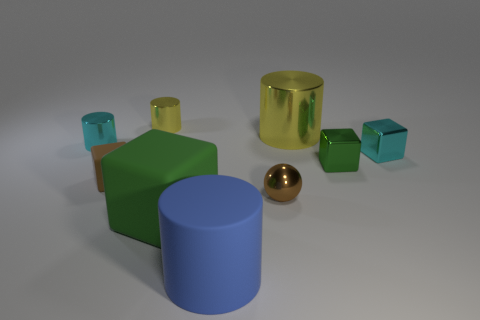What shape is the brown object on the right side of the green matte block?
Your answer should be compact. Sphere. The green metal thing that is the same size as the cyan cube is what shape?
Give a very brief answer. Cube. The large object that is to the right of the big cylinder that is in front of the tiny cyan object left of the big cube is what color?
Your response must be concise. Yellow. Do the large shiny object and the blue rubber thing have the same shape?
Give a very brief answer. Yes. Is the number of big green blocks in front of the large rubber cylinder the same as the number of small green cubes?
Make the answer very short. No. How many other objects are there of the same material as the blue object?
Make the answer very short. 2. Do the metal object that is in front of the small brown rubber thing and the metallic cylinder on the right side of the green rubber object have the same size?
Provide a succinct answer. No. How many things are cyan shiny objects behind the cyan block or tiny blocks that are on the right side of the green matte object?
Your response must be concise. 3. Are there any other things that have the same shape as the small green metallic thing?
Ensure brevity in your answer.  Yes. There is a tiny metallic cylinder in front of the small yellow object; is it the same color as the tiny shiny object that is behind the large yellow cylinder?
Your answer should be very brief. No. 